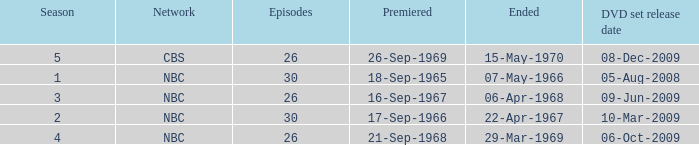What is the total season number for episodes later than episode 30? None. 